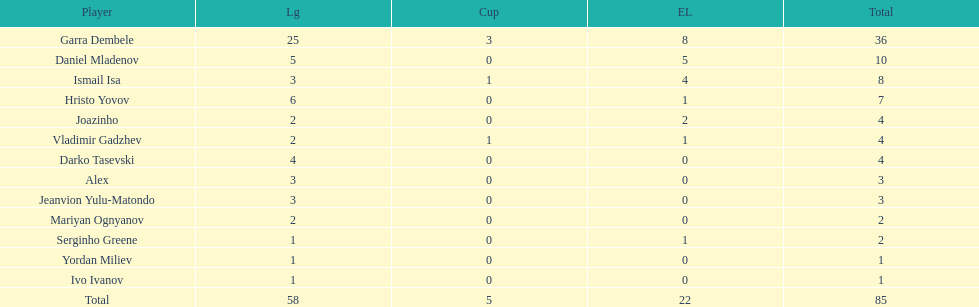How many players did not score a goal in cup play? 10. 